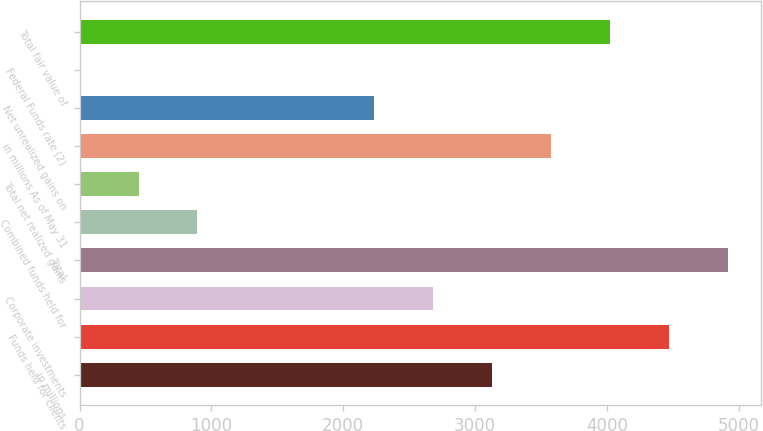<chart> <loc_0><loc_0><loc_500><loc_500><bar_chart><fcel>in millions<fcel>Funds held for clients<fcel>Corporate investments<fcel>Total<fcel>Combined funds held for<fcel>Total net realized gains<fcel>in millions As of May 31<fcel>Net unrealized gains on<fcel>Federal Funds rate (2)<fcel>Total fair value of<nl><fcel>3130.84<fcel>4472.53<fcel>2683.61<fcel>4919.76<fcel>894.71<fcel>447.48<fcel>3578.07<fcel>2236.39<fcel>0.25<fcel>4025.3<nl></chart> 